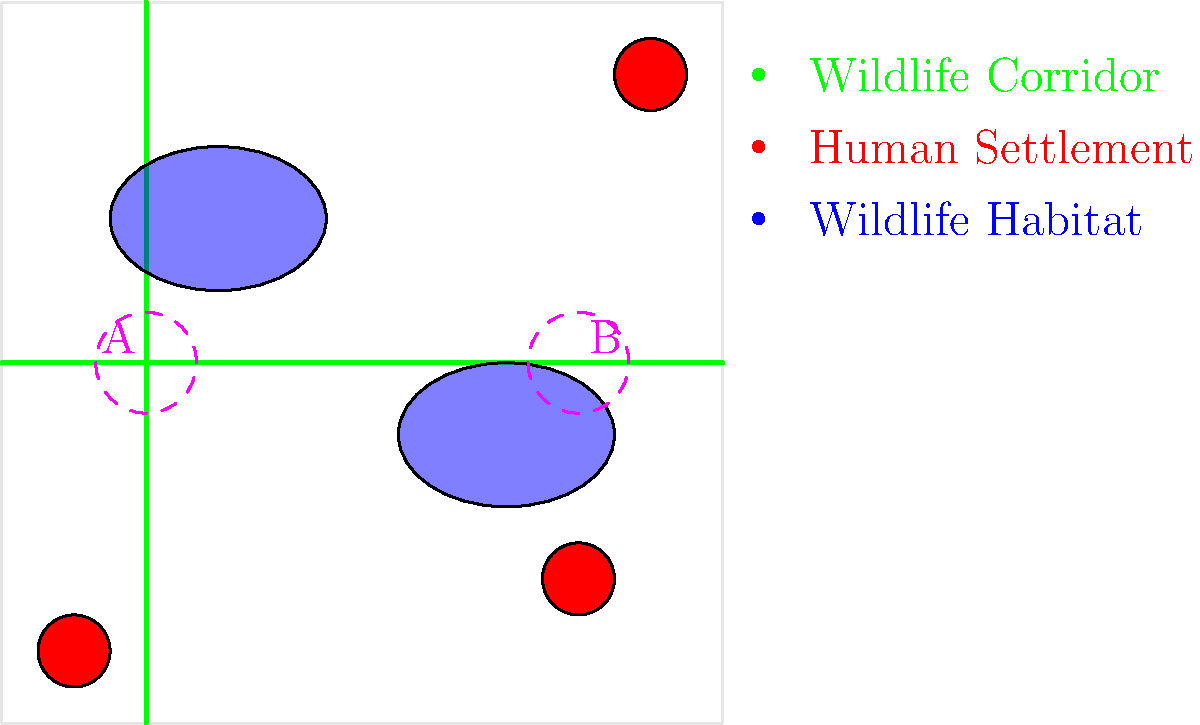Based on the map of wildlife corridors and human settlements, which area (A or B) is likely to have a higher potential for human-wildlife conflict, and why? To determine which area has a higher potential for human-wildlife conflict, we need to analyze the map and consider the following factors:

1. Proximity to human settlements:
   - Area A is not directly adjacent to any human settlement.
   - Area B is close to a human settlement in the bottom right corner.

2. Intersection of wildlife corridors:
   - Both areas A and B are located at the intersection of two wildlife corridors.

3. Proximity to wildlife habitats:
   - Area A is closer to a wildlife habitat (blue ellipse in the top left).
   - Area B is also near a wildlife habitat, but slightly farther than Area A.

4. Number of intersecting corridors:
   - Both areas have two intersecting corridors, which increases the likelihood of wildlife movement.

5. Potential for human activity:
   - Area B is closer to human settlements, suggesting a higher likelihood of human activity in this area.

Considering these factors, Area B has a higher potential for human-wildlife conflict because:

1. It is closer to a human settlement, increasing the chances of direct encounters between humans and wildlife.
2. It is still near a wildlife habitat and at the intersection of two corridors, ensuring frequent wildlife movement.
3. The proximity to human settlements suggests more human activity in the area, such as agriculture or development, which could lead to habitat encroachment and resource competition.

While Area A is also a potential conflict zone due to its location at the intersection of wildlife corridors and proximity to a habitat, its distance from human settlements reduces the immediate risk of conflict.
Answer: Area B 